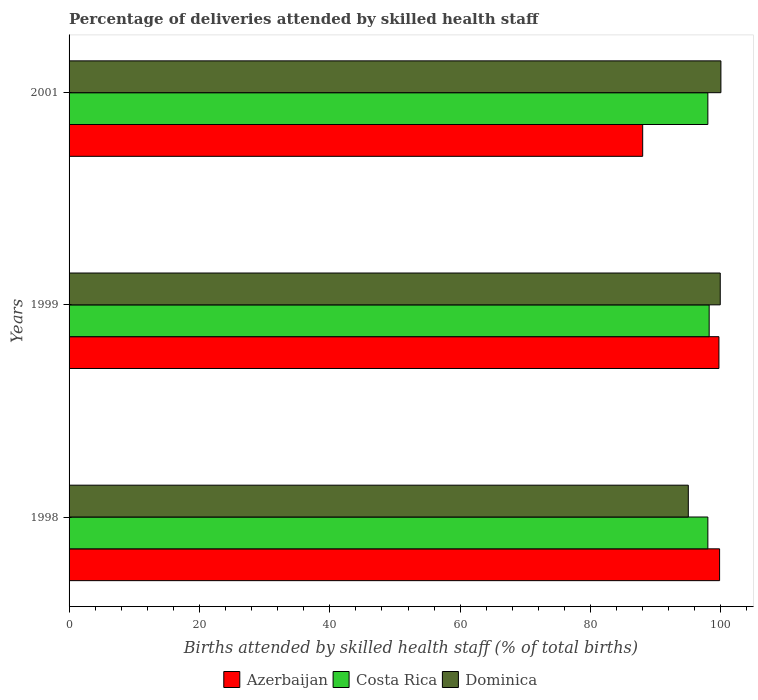What is the label of the 2nd group of bars from the top?
Provide a succinct answer. 1999. What is the percentage of births attended by skilled health staff in Costa Rica in 2001?
Offer a very short reply. 98. Across all years, what is the maximum percentage of births attended by skilled health staff in Azerbaijan?
Offer a very short reply. 99.8. In which year was the percentage of births attended by skilled health staff in Dominica maximum?
Your response must be concise. 2001. In which year was the percentage of births attended by skilled health staff in Dominica minimum?
Your answer should be compact. 1998. What is the total percentage of births attended by skilled health staff in Dominica in the graph?
Keep it short and to the point. 294.9. What is the difference between the percentage of births attended by skilled health staff in Azerbaijan in 1999 and that in 2001?
Ensure brevity in your answer.  11.7. What is the difference between the percentage of births attended by skilled health staff in Azerbaijan in 1998 and the percentage of births attended by skilled health staff in Costa Rica in 1999?
Offer a very short reply. 1.6. What is the average percentage of births attended by skilled health staff in Azerbaijan per year?
Give a very brief answer. 95.83. In the year 1999, what is the difference between the percentage of births attended by skilled health staff in Dominica and percentage of births attended by skilled health staff in Azerbaijan?
Offer a very short reply. 0.2. In how many years, is the percentage of births attended by skilled health staff in Costa Rica greater than 56 %?
Provide a short and direct response. 3. What is the ratio of the percentage of births attended by skilled health staff in Costa Rica in 1999 to that in 2001?
Your answer should be compact. 1. Is the difference between the percentage of births attended by skilled health staff in Dominica in 1998 and 2001 greater than the difference between the percentage of births attended by skilled health staff in Azerbaijan in 1998 and 2001?
Provide a short and direct response. No. What is the difference between the highest and the second highest percentage of births attended by skilled health staff in Azerbaijan?
Provide a succinct answer. 0.1. What is the difference between the highest and the lowest percentage of births attended by skilled health staff in Dominica?
Your answer should be compact. 5. What does the 1st bar from the top in 1998 represents?
Give a very brief answer. Dominica. What does the 1st bar from the bottom in 2001 represents?
Keep it short and to the point. Azerbaijan. Are all the bars in the graph horizontal?
Keep it short and to the point. Yes. How many years are there in the graph?
Your answer should be compact. 3. Are the values on the major ticks of X-axis written in scientific E-notation?
Your answer should be very brief. No. Does the graph contain any zero values?
Provide a succinct answer. No. Where does the legend appear in the graph?
Provide a short and direct response. Bottom center. How are the legend labels stacked?
Make the answer very short. Horizontal. What is the title of the graph?
Keep it short and to the point. Percentage of deliveries attended by skilled health staff. What is the label or title of the X-axis?
Your answer should be very brief. Births attended by skilled health staff (% of total births). What is the Births attended by skilled health staff (% of total births) in Azerbaijan in 1998?
Your answer should be compact. 99.8. What is the Births attended by skilled health staff (% of total births) of Costa Rica in 1998?
Your response must be concise. 98. What is the Births attended by skilled health staff (% of total births) in Dominica in 1998?
Provide a short and direct response. 95. What is the Births attended by skilled health staff (% of total births) of Azerbaijan in 1999?
Give a very brief answer. 99.7. What is the Births attended by skilled health staff (% of total births) in Costa Rica in 1999?
Give a very brief answer. 98.2. What is the Births attended by skilled health staff (% of total births) in Dominica in 1999?
Offer a very short reply. 99.9. Across all years, what is the maximum Births attended by skilled health staff (% of total births) in Azerbaijan?
Your answer should be compact. 99.8. Across all years, what is the maximum Births attended by skilled health staff (% of total births) in Costa Rica?
Give a very brief answer. 98.2. Across all years, what is the minimum Births attended by skilled health staff (% of total births) in Azerbaijan?
Offer a very short reply. 88. What is the total Births attended by skilled health staff (% of total births) of Azerbaijan in the graph?
Provide a succinct answer. 287.5. What is the total Births attended by skilled health staff (% of total births) of Costa Rica in the graph?
Give a very brief answer. 294.2. What is the total Births attended by skilled health staff (% of total births) of Dominica in the graph?
Your answer should be compact. 294.9. What is the difference between the Births attended by skilled health staff (% of total births) of Azerbaijan in 1998 and that in 2001?
Ensure brevity in your answer.  11.8. What is the difference between the Births attended by skilled health staff (% of total births) in Costa Rica in 1998 and that in 2001?
Give a very brief answer. 0. What is the difference between the Births attended by skilled health staff (% of total births) in Dominica in 1998 and that in 2001?
Your answer should be very brief. -5. What is the difference between the Births attended by skilled health staff (% of total births) of Azerbaijan in 1999 and that in 2001?
Your answer should be very brief. 11.7. What is the difference between the Births attended by skilled health staff (% of total births) of Dominica in 1999 and that in 2001?
Your response must be concise. -0.1. What is the difference between the Births attended by skilled health staff (% of total births) in Azerbaijan in 1998 and the Births attended by skilled health staff (% of total births) in Dominica in 1999?
Keep it short and to the point. -0.1. What is the difference between the Births attended by skilled health staff (% of total births) in Costa Rica in 1998 and the Births attended by skilled health staff (% of total births) in Dominica in 2001?
Your response must be concise. -2. What is the difference between the Births attended by skilled health staff (% of total births) of Azerbaijan in 1999 and the Births attended by skilled health staff (% of total births) of Dominica in 2001?
Provide a succinct answer. -0.3. What is the difference between the Births attended by skilled health staff (% of total births) of Costa Rica in 1999 and the Births attended by skilled health staff (% of total births) of Dominica in 2001?
Keep it short and to the point. -1.8. What is the average Births attended by skilled health staff (% of total births) in Azerbaijan per year?
Your answer should be very brief. 95.83. What is the average Births attended by skilled health staff (% of total births) in Costa Rica per year?
Your answer should be very brief. 98.07. What is the average Births attended by skilled health staff (% of total births) of Dominica per year?
Provide a short and direct response. 98.3. In the year 1999, what is the difference between the Births attended by skilled health staff (% of total births) of Azerbaijan and Births attended by skilled health staff (% of total births) of Costa Rica?
Keep it short and to the point. 1.5. In the year 2001, what is the difference between the Births attended by skilled health staff (% of total births) of Azerbaijan and Births attended by skilled health staff (% of total births) of Costa Rica?
Offer a very short reply. -10. In the year 2001, what is the difference between the Births attended by skilled health staff (% of total births) in Azerbaijan and Births attended by skilled health staff (% of total births) in Dominica?
Give a very brief answer. -12. What is the ratio of the Births attended by skilled health staff (% of total births) of Azerbaijan in 1998 to that in 1999?
Offer a terse response. 1. What is the ratio of the Births attended by skilled health staff (% of total births) of Dominica in 1998 to that in 1999?
Make the answer very short. 0.95. What is the ratio of the Births attended by skilled health staff (% of total births) in Azerbaijan in 1998 to that in 2001?
Make the answer very short. 1.13. What is the ratio of the Births attended by skilled health staff (% of total births) of Dominica in 1998 to that in 2001?
Offer a very short reply. 0.95. What is the ratio of the Births attended by skilled health staff (% of total births) of Azerbaijan in 1999 to that in 2001?
Offer a terse response. 1.13. What is the difference between the highest and the second highest Births attended by skilled health staff (% of total births) of Costa Rica?
Give a very brief answer. 0.2. What is the difference between the highest and the second highest Births attended by skilled health staff (% of total births) in Dominica?
Your response must be concise. 0.1. What is the difference between the highest and the lowest Births attended by skilled health staff (% of total births) of Azerbaijan?
Provide a succinct answer. 11.8. 